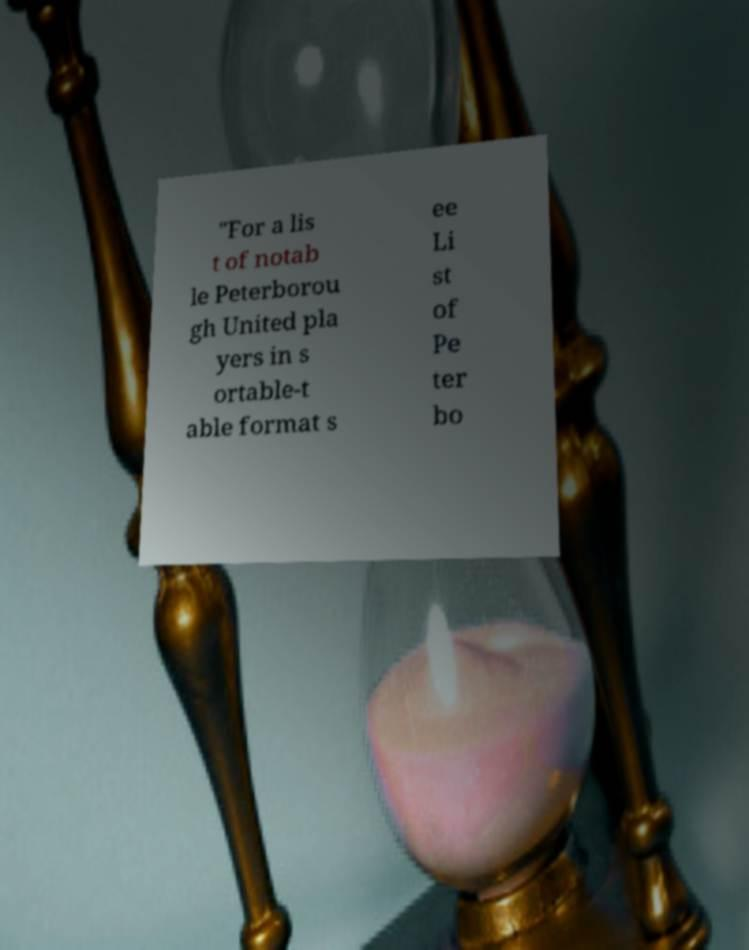Could you extract and type out the text from this image? "For a lis t of notab le Peterborou gh United pla yers in s ortable-t able format s ee Li st of Pe ter bo 